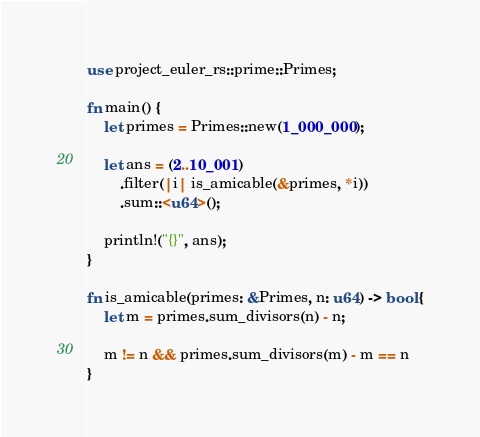<code> <loc_0><loc_0><loc_500><loc_500><_Rust_>use project_euler_rs::prime::Primes;

fn main() {
	let primes = Primes::new(1_000_000);

	let ans = (2..10_001)
		.filter(|i| is_amicable(&primes, *i))
		.sum::<u64>();

	println!("{}", ans);
}

fn is_amicable(primes: &Primes, n: u64) -> bool {
	let m = primes.sum_divisors(n) - n;

	m != n && primes.sum_divisors(m) - m == n
}
</code> 